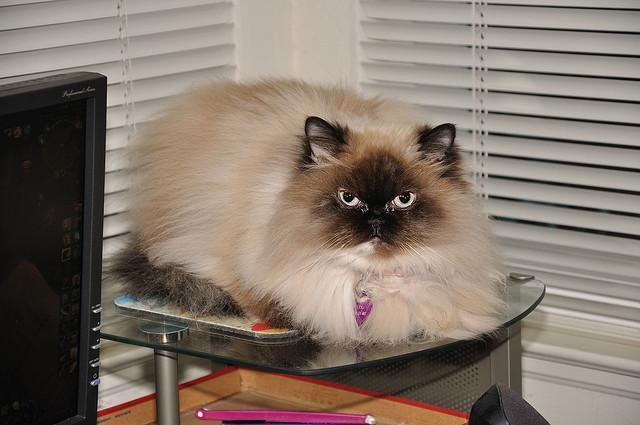How many windows?
Give a very brief answer. 2. 